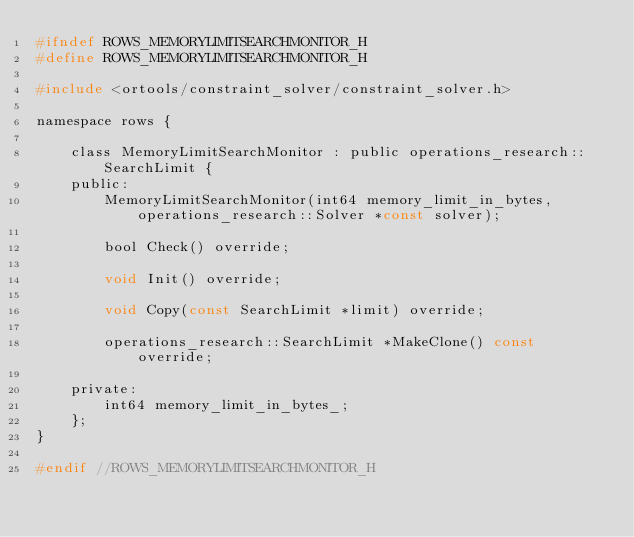<code> <loc_0><loc_0><loc_500><loc_500><_C_>#ifndef ROWS_MEMORYLIMITSEARCHMONITOR_H
#define ROWS_MEMORYLIMITSEARCHMONITOR_H

#include <ortools/constraint_solver/constraint_solver.h>

namespace rows {

    class MemoryLimitSearchMonitor : public operations_research::SearchLimit {
    public:
        MemoryLimitSearchMonitor(int64 memory_limit_in_bytes, operations_research::Solver *const solver);

        bool Check() override;

        void Init() override;

        void Copy(const SearchLimit *limit) override;

        operations_research::SearchLimit *MakeClone() const override;

    private:
        int64 memory_limit_in_bytes_;
    };
}

#endif //ROWS_MEMORYLIMITSEARCHMONITOR_H
</code> 